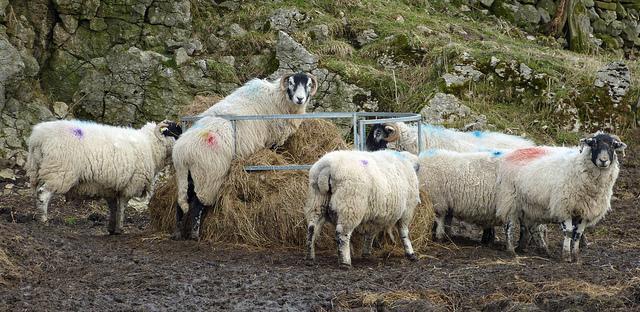What word is related to these animals?
From the following four choices, select the correct answer to address the question.
Options: Beef, ewe, kitten, joey. Ewe. What are all of the sheep gathering around in their field?
Make your selection and explain in format: 'Answer: answer
Rationale: rationale.'
Options: Dog, hay, gate, salt lick. Answer: hay.
Rationale: The sheep are eating the hay. 